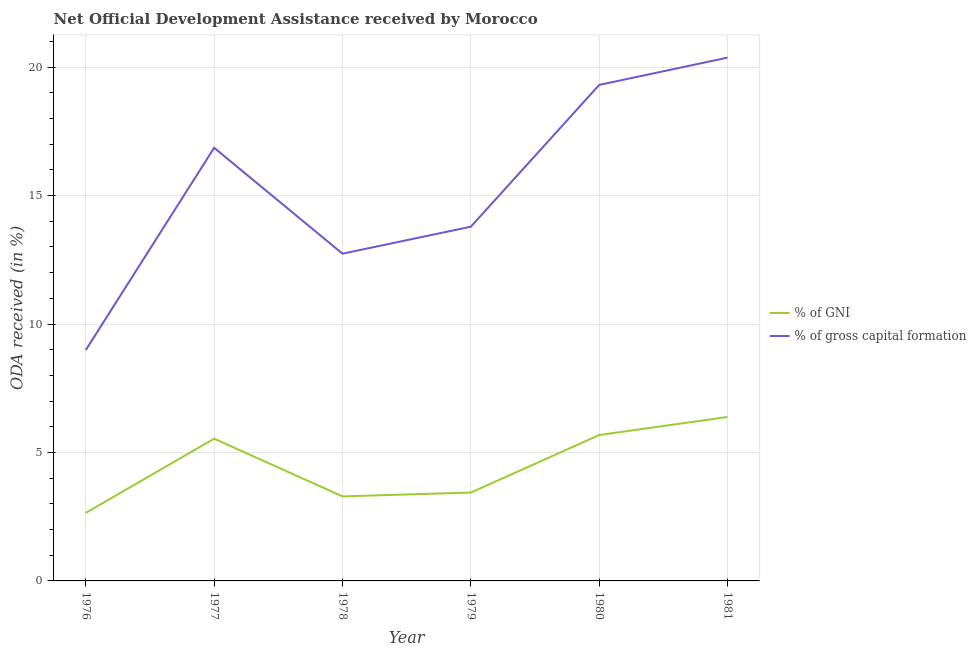Does the line corresponding to oda received as percentage of gni intersect with the line corresponding to oda received as percentage of gross capital formation?
Your response must be concise. No. What is the oda received as percentage of gross capital formation in 1978?
Ensure brevity in your answer.  12.74. Across all years, what is the maximum oda received as percentage of gross capital formation?
Offer a terse response. 20.37. Across all years, what is the minimum oda received as percentage of gross capital formation?
Make the answer very short. 8.99. In which year was the oda received as percentage of gross capital formation minimum?
Your response must be concise. 1976. What is the total oda received as percentage of gni in the graph?
Keep it short and to the point. 26.98. What is the difference between the oda received as percentage of gross capital formation in 1977 and that in 1979?
Your answer should be very brief. 3.07. What is the difference between the oda received as percentage of gross capital formation in 1980 and the oda received as percentage of gni in 1977?
Provide a short and direct response. 13.77. What is the average oda received as percentage of gni per year?
Offer a very short reply. 4.5. In the year 1976, what is the difference between the oda received as percentage of gni and oda received as percentage of gross capital formation?
Ensure brevity in your answer.  -6.34. What is the ratio of the oda received as percentage of gross capital formation in 1978 to that in 1979?
Provide a short and direct response. 0.92. Is the oda received as percentage of gni in 1976 less than that in 1979?
Your answer should be compact. Yes. What is the difference between the highest and the second highest oda received as percentage of gni?
Your answer should be compact. 0.7. What is the difference between the highest and the lowest oda received as percentage of gross capital formation?
Your answer should be very brief. 11.38. In how many years, is the oda received as percentage of gni greater than the average oda received as percentage of gni taken over all years?
Your answer should be very brief. 3. Is the sum of the oda received as percentage of gni in 1976 and 1980 greater than the maximum oda received as percentage of gross capital formation across all years?
Offer a very short reply. No. Does the oda received as percentage of gross capital formation monotonically increase over the years?
Provide a succinct answer. No. Is the oda received as percentage of gross capital formation strictly less than the oda received as percentage of gni over the years?
Keep it short and to the point. No. What is the difference between two consecutive major ticks on the Y-axis?
Provide a succinct answer. 5. Are the values on the major ticks of Y-axis written in scientific E-notation?
Provide a succinct answer. No. Does the graph contain any zero values?
Your response must be concise. No. Does the graph contain grids?
Provide a short and direct response. Yes. How are the legend labels stacked?
Offer a very short reply. Vertical. What is the title of the graph?
Make the answer very short. Net Official Development Assistance received by Morocco. What is the label or title of the Y-axis?
Your answer should be very brief. ODA received (in %). What is the ODA received (in %) in % of GNI in 1976?
Offer a very short reply. 2.65. What is the ODA received (in %) in % of gross capital formation in 1976?
Keep it short and to the point. 8.99. What is the ODA received (in %) of % of GNI in 1977?
Offer a terse response. 5.54. What is the ODA received (in %) of % of gross capital formation in 1977?
Your answer should be compact. 16.86. What is the ODA received (in %) in % of GNI in 1978?
Give a very brief answer. 3.29. What is the ODA received (in %) in % of gross capital formation in 1978?
Provide a succinct answer. 12.74. What is the ODA received (in %) of % of GNI in 1979?
Offer a terse response. 3.44. What is the ODA received (in %) of % of gross capital formation in 1979?
Make the answer very short. 13.79. What is the ODA received (in %) of % of GNI in 1980?
Keep it short and to the point. 5.68. What is the ODA received (in %) of % of gross capital formation in 1980?
Ensure brevity in your answer.  19.31. What is the ODA received (in %) in % of GNI in 1981?
Your answer should be compact. 6.38. What is the ODA received (in %) of % of gross capital formation in 1981?
Make the answer very short. 20.37. Across all years, what is the maximum ODA received (in %) of % of GNI?
Provide a succinct answer. 6.38. Across all years, what is the maximum ODA received (in %) of % of gross capital formation?
Make the answer very short. 20.37. Across all years, what is the minimum ODA received (in %) of % of GNI?
Ensure brevity in your answer.  2.65. Across all years, what is the minimum ODA received (in %) in % of gross capital formation?
Make the answer very short. 8.99. What is the total ODA received (in %) of % of GNI in the graph?
Make the answer very short. 26.98. What is the total ODA received (in %) of % of gross capital formation in the graph?
Provide a short and direct response. 92.05. What is the difference between the ODA received (in %) of % of GNI in 1976 and that in 1977?
Your answer should be compact. -2.89. What is the difference between the ODA received (in %) in % of gross capital formation in 1976 and that in 1977?
Ensure brevity in your answer.  -7.87. What is the difference between the ODA received (in %) of % of GNI in 1976 and that in 1978?
Make the answer very short. -0.64. What is the difference between the ODA received (in %) of % of gross capital formation in 1976 and that in 1978?
Your response must be concise. -3.75. What is the difference between the ODA received (in %) of % of GNI in 1976 and that in 1979?
Provide a short and direct response. -0.79. What is the difference between the ODA received (in %) of % of gross capital formation in 1976 and that in 1979?
Offer a very short reply. -4.8. What is the difference between the ODA received (in %) in % of GNI in 1976 and that in 1980?
Provide a succinct answer. -3.03. What is the difference between the ODA received (in %) in % of gross capital formation in 1976 and that in 1980?
Offer a terse response. -10.32. What is the difference between the ODA received (in %) of % of GNI in 1976 and that in 1981?
Your answer should be very brief. -3.73. What is the difference between the ODA received (in %) in % of gross capital formation in 1976 and that in 1981?
Keep it short and to the point. -11.38. What is the difference between the ODA received (in %) in % of GNI in 1977 and that in 1978?
Offer a terse response. 2.25. What is the difference between the ODA received (in %) in % of gross capital formation in 1977 and that in 1978?
Provide a succinct answer. 4.12. What is the difference between the ODA received (in %) of % of GNI in 1977 and that in 1979?
Provide a succinct answer. 2.1. What is the difference between the ODA received (in %) in % of gross capital formation in 1977 and that in 1979?
Your answer should be compact. 3.07. What is the difference between the ODA received (in %) of % of GNI in 1977 and that in 1980?
Your response must be concise. -0.14. What is the difference between the ODA received (in %) in % of gross capital formation in 1977 and that in 1980?
Make the answer very short. -2.45. What is the difference between the ODA received (in %) of % of GNI in 1977 and that in 1981?
Your answer should be very brief. -0.84. What is the difference between the ODA received (in %) in % of gross capital formation in 1977 and that in 1981?
Offer a very short reply. -3.51. What is the difference between the ODA received (in %) in % of GNI in 1978 and that in 1979?
Provide a short and direct response. -0.15. What is the difference between the ODA received (in %) in % of gross capital formation in 1978 and that in 1979?
Your answer should be compact. -1.05. What is the difference between the ODA received (in %) in % of GNI in 1978 and that in 1980?
Provide a short and direct response. -2.39. What is the difference between the ODA received (in %) of % of gross capital formation in 1978 and that in 1980?
Give a very brief answer. -6.57. What is the difference between the ODA received (in %) in % of GNI in 1978 and that in 1981?
Your answer should be very brief. -3.09. What is the difference between the ODA received (in %) of % of gross capital formation in 1978 and that in 1981?
Offer a very short reply. -7.63. What is the difference between the ODA received (in %) in % of GNI in 1979 and that in 1980?
Offer a very short reply. -2.24. What is the difference between the ODA received (in %) of % of gross capital formation in 1979 and that in 1980?
Your response must be concise. -5.52. What is the difference between the ODA received (in %) of % of GNI in 1979 and that in 1981?
Give a very brief answer. -2.94. What is the difference between the ODA received (in %) in % of gross capital formation in 1979 and that in 1981?
Offer a terse response. -6.58. What is the difference between the ODA received (in %) of % of GNI in 1980 and that in 1981?
Your answer should be very brief. -0.7. What is the difference between the ODA received (in %) in % of gross capital formation in 1980 and that in 1981?
Your answer should be very brief. -1.06. What is the difference between the ODA received (in %) in % of GNI in 1976 and the ODA received (in %) in % of gross capital formation in 1977?
Provide a succinct answer. -14.21. What is the difference between the ODA received (in %) of % of GNI in 1976 and the ODA received (in %) of % of gross capital formation in 1978?
Offer a terse response. -10.09. What is the difference between the ODA received (in %) of % of GNI in 1976 and the ODA received (in %) of % of gross capital formation in 1979?
Provide a succinct answer. -11.14. What is the difference between the ODA received (in %) in % of GNI in 1976 and the ODA received (in %) in % of gross capital formation in 1980?
Your response must be concise. -16.66. What is the difference between the ODA received (in %) of % of GNI in 1976 and the ODA received (in %) of % of gross capital formation in 1981?
Keep it short and to the point. -17.72. What is the difference between the ODA received (in %) of % of GNI in 1977 and the ODA received (in %) of % of gross capital formation in 1978?
Provide a short and direct response. -7.2. What is the difference between the ODA received (in %) of % of GNI in 1977 and the ODA received (in %) of % of gross capital formation in 1979?
Your answer should be compact. -8.25. What is the difference between the ODA received (in %) in % of GNI in 1977 and the ODA received (in %) in % of gross capital formation in 1980?
Offer a very short reply. -13.77. What is the difference between the ODA received (in %) of % of GNI in 1977 and the ODA received (in %) of % of gross capital formation in 1981?
Provide a succinct answer. -14.83. What is the difference between the ODA received (in %) in % of GNI in 1978 and the ODA received (in %) in % of gross capital formation in 1979?
Ensure brevity in your answer.  -10.5. What is the difference between the ODA received (in %) in % of GNI in 1978 and the ODA received (in %) in % of gross capital formation in 1980?
Give a very brief answer. -16.02. What is the difference between the ODA received (in %) in % of GNI in 1978 and the ODA received (in %) in % of gross capital formation in 1981?
Ensure brevity in your answer.  -17.08. What is the difference between the ODA received (in %) in % of GNI in 1979 and the ODA received (in %) in % of gross capital formation in 1980?
Your answer should be very brief. -15.87. What is the difference between the ODA received (in %) of % of GNI in 1979 and the ODA received (in %) of % of gross capital formation in 1981?
Give a very brief answer. -16.93. What is the difference between the ODA received (in %) in % of GNI in 1980 and the ODA received (in %) in % of gross capital formation in 1981?
Offer a terse response. -14.69. What is the average ODA received (in %) in % of GNI per year?
Provide a succinct answer. 4.5. What is the average ODA received (in %) in % of gross capital formation per year?
Provide a short and direct response. 15.34. In the year 1976, what is the difference between the ODA received (in %) in % of GNI and ODA received (in %) in % of gross capital formation?
Offer a terse response. -6.34. In the year 1977, what is the difference between the ODA received (in %) in % of GNI and ODA received (in %) in % of gross capital formation?
Provide a succinct answer. -11.32. In the year 1978, what is the difference between the ODA received (in %) of % of GNI and ODA received (in %) of % of gross capital formation?
Your answer should be compact. -9.45. In the year 1979, what is the difference between the ODA received (in %) in % of GNI and ODA received (in %) in % of gross capital formation?
Provide a succinct answer. -10.35. In the year 1980, what is the difference between the ODA received (in %) of % of GNI and ODA received (in %) of % of gross capital formation?
Keep it short and to the point. -13.63. In the year 1981, what is the difference between the ODA received (in %) in % of GNI and ODA received (in %) in % of gross capital formation?
Offer a terse response. -13.99. What is the ratio of the ODA received (in %) of % of GNI in 1976 to that in 1977?
Your response must be concise. 0.48. What is the ratio of the ODA received (in %) of % of gross capital formation in 1976 to that in 1977?
Provide a short and direct response. 0.53. What is the ratio of the ODA received (in %) of % of GNI in 1976 to that in 1978?
Offer a terse response. 0.8. What is the ratio of the ODA received (in %) of % of gross capital formation in 1976 to that in 1978?
Offer a very short reply. 0.71. What is the ratio of the ODA received (in %) of % of GNI in 1976 to that in 1979?
Provide a succinct answer. 0.77. What is the ratio of the ODA received (in %) in % of gross capital formation in 1976 to that in 1979?
Provide a short and direct response. 0.65. What is the ratio of the ODA received (in %) of % of GNI in 1976 to that in 1980?
Keep it short and to the point. 0.47. What is the ratio of the ODA received (in %) in % of gross capital formation in 1976 to that in 1980?
Make the answer very short. 0.47. What is the ratio of the ODA received (in %) of % of GNI in 1976 to that in 1981?
Your answer should be very brief. 0.41. What is the ratio of the ODA received (in %) in % of gross capital formation in 1976 to that in 1981?
Your response must be concise. 0.44. What is the ratio of the ODA received (in %) in % of GNI in 1977 to that in 1978?
Keep it short and to the point. 1.68. What is the ratio of the ODA received (in %) of % of gross capital formation in 1977 to that in 1978?
Give a very brief answer. 1.32. What is the ratio of the ODA received (in %) in % of GNI in 1977 to that in 1979?
Provide a short and direct response. 1.61. What is the ratio of the ODA received (in %) in % of gross capital formation in 1977 to that in 1979?
Offer a very short reply. 1.22. What is the ratio of the ODA received (in %) in % of GNI in 1977 to that in 1980?
Keep it short and to the point. 0.98. What is the ratio of the ODA received (in %) of % of gross capital formation in 1977 to that in 1980?
Your response must be concise. 0.87. What is the ratio of the ODA received (in %) of % of GNI in 1977 to that in 1981?
Provide a short and direct response. 0.87. What is the ratio of the ODA received (in %) in % of gross capital formation in 1977 to that in 1981?
Offer a terse response. 0.83. What is the ratio of the ODA received (in %) in % of GNI in 1978 to that in 1979?
Your answer should be very brief. 0.96. What is the ratio of the ODA received (in %) in % of gross capital formation in 1978 to that in 1979?
Make the answer very short. 0.92. What is the ratio of the ODA received (in %) in % of GNI in 1978 to that in 1980?
Offer a very short reply. 0.58. What is the ratio of the ODA received (in %) of % of gross capital formation in 1978 to that in 1980?
Provide a short and direct response. 0.66. What is the ratio of the ODA received (in %) of % of GNI in 1978 to that in 1981?
Give a very brief answer. 0.52. What is the ratio of the ODA received (in %) of % of gross capital formation in 1978 to that in 1981?
Make the answer very short. 0.63. What is the ratio of the ODA received (in %) of % of GNI in 1979 to that in 1980?
Offer a terse response. 0.61. What is the ratio of the ODA received (in %) in % of gross capital formation in 1979 to that in 1980?
Provide a succinct answer. 0.71. What is the ratio of the ODA received (in %) in % of GNI in 1979 to that in 1981?
Offer a terse response. 0.54. What is the ratio of the ODA received (in %) in % of gross capital formation in 1979 to that in 1981?
Your answer should be very brief. 0.68. What is the ratio of the ODA received (in %) in % of GNI in 1980 to that in 1981?
Your answer should be very brief. 0.89. What is the ratio of the ODA received (in %) of % of gross capital formation in 1980 to that in 1981?
Provide a short and direct response. 0.95. What is the difference between the highest and the second highest ODA received (in %) in % of GNI?
Provide a short and direct response. 0.7. What is the difference between the highest and the second highest ODA received (in %) in % of gross capital formation?
Keep it short and to the point. 1.06. What is the difference between the highest and the lowest ODA received (in %) in % of GNI?
Your answer should be very brief. 3.73. What is the difference between the highest and the lowest ODA received (in %) of % of gross capital formation?
Your answer should be very brief. 11.38. 